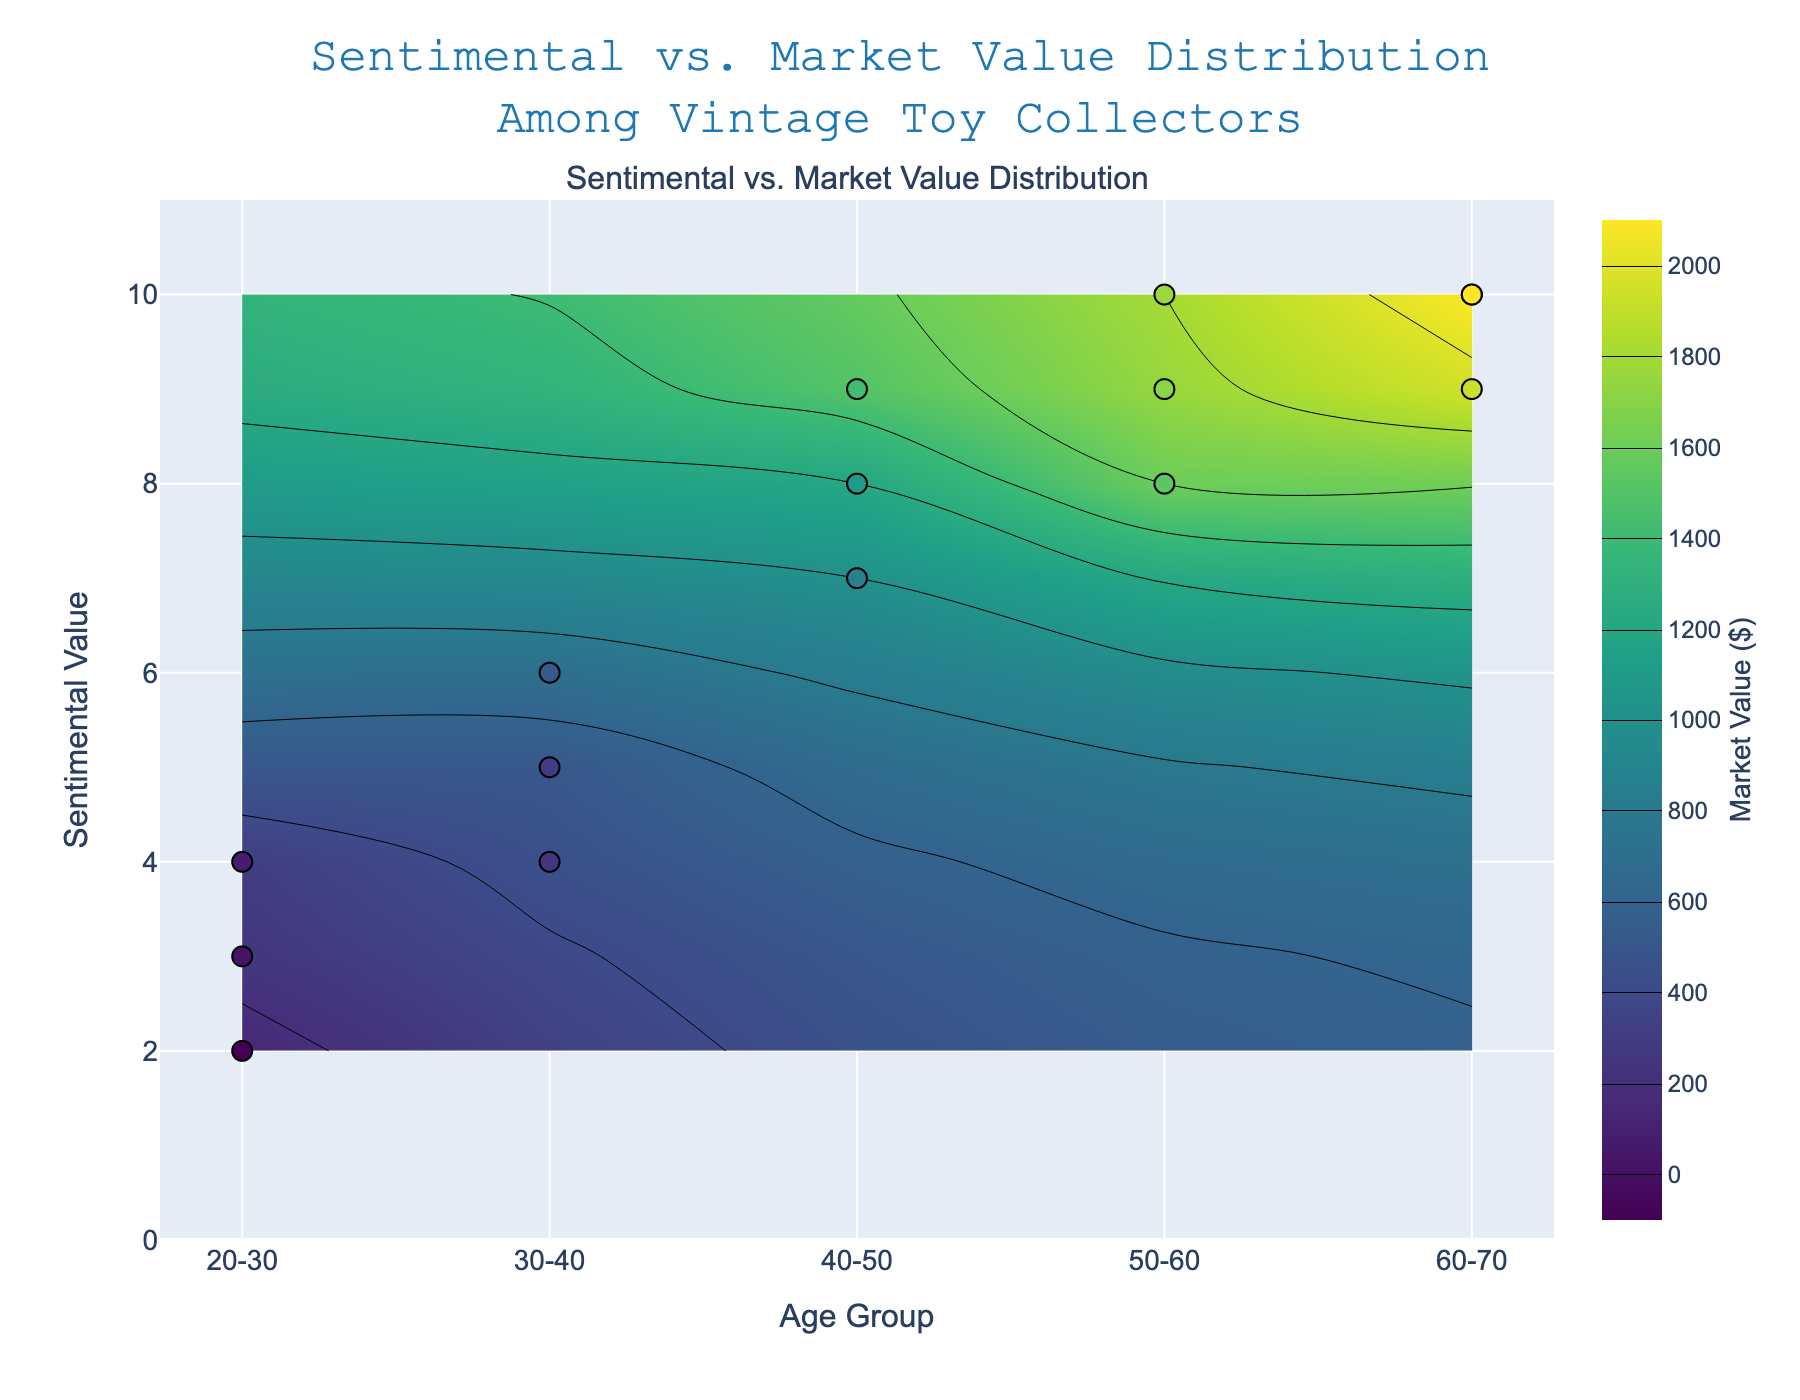What is the title of the figure? The title is displayed at the top center of the figure. It reads "Sentimental vs. Market Value Distribution Among Vintage Toy Collectors"
Answer: Sentimental vs. Market Value Distribution Among Vintage Toy Collectors What are the ranges for the sentimental value on the y-axis? The y-axis displays the range for sentimental value, which starts at 0 and ends at 11
Answer: 0 to 11 Which age group has the highest sentimental value? By examining the y-values, the age group showing a sentimental value of 10 is "60-70"
Answer: 60-70 How many different age groups are represented in the figure? The x-axis contains labelled tick marks representing age groups. There are five unique age group labels: "20-30", "30-40", "40-50", "50-60", "60-70"
Answer: 5 In which age group is the market value the lowest? Inspecting the hover text for the scatter points, the lowest market value is $150 for the "20-30" age group
Answer: 20-30 What is the average sentimental value for the "50-60" age group? The sentimental values for the "50-60" age group are 10, 8, and 9. Summing these values: 10 + 8 + 9 = 27. The average is 27/3 = 9
Answer: 9 Which age group has the highest market value, and what is that value? By looking at the highest point in the colorbar's range on the contour plot and hover text, the "60-70" age group has a market value of $2100
Answer: 60-70, $2100 Is there a correlation between sentimental value and market value? By observing the scatter points on the contour, higher sentimental values seem to correspond to higher market values, indicating a positive correlation
Answer: Yes What is the median sentimental value for the "40-50" age group? For the "40-50" age group, the sentimental values are 8, 7, and 9. When these values are sorted: 7, 8, 9. The median value is the middle one, which is 8
Answer: 8 Compare the sentimental values between the "30-40" and "40-50" age groups. Which group has the higher average sentimental value? The "30-40" age group has sentimental values of 5, 4, and 6. Their average is (5+4+6)/3 = 5. The "40-50" age group has values of 8, 7, and 9, with an average of (8+7+9)/3 = 8. Hence, "40-50" has the higher average
Answer: 40-50 